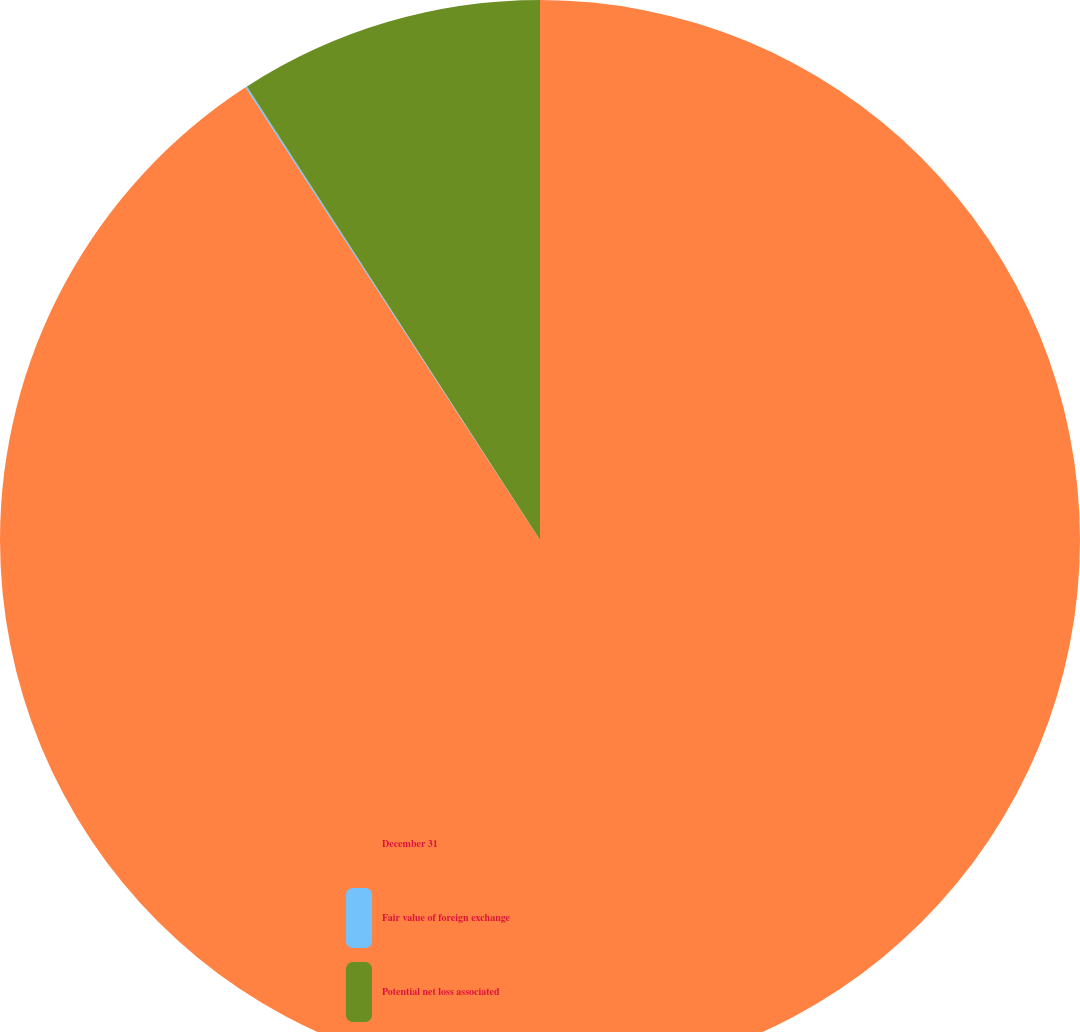<chart> <loc_0><loc_0><loc_500><loc_500><pie_chart><fcel>December 31<fcel>Fair value of foreign exchange<fcel>Potential net loss associated<nl><fcel>90.82%<fcel>0.05%<fcel>9.13%<nl></chart> 